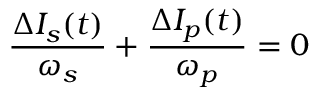Convert formula to latex. <formula><loc_0><loc_0><loc_500><loc_500>\frac { \Delta I _ { s } ( t ) } { \omega _ { s } } + \frac { \Delta I _ { p } ( t ) } { \omega _ { p } } = 0</formula> 